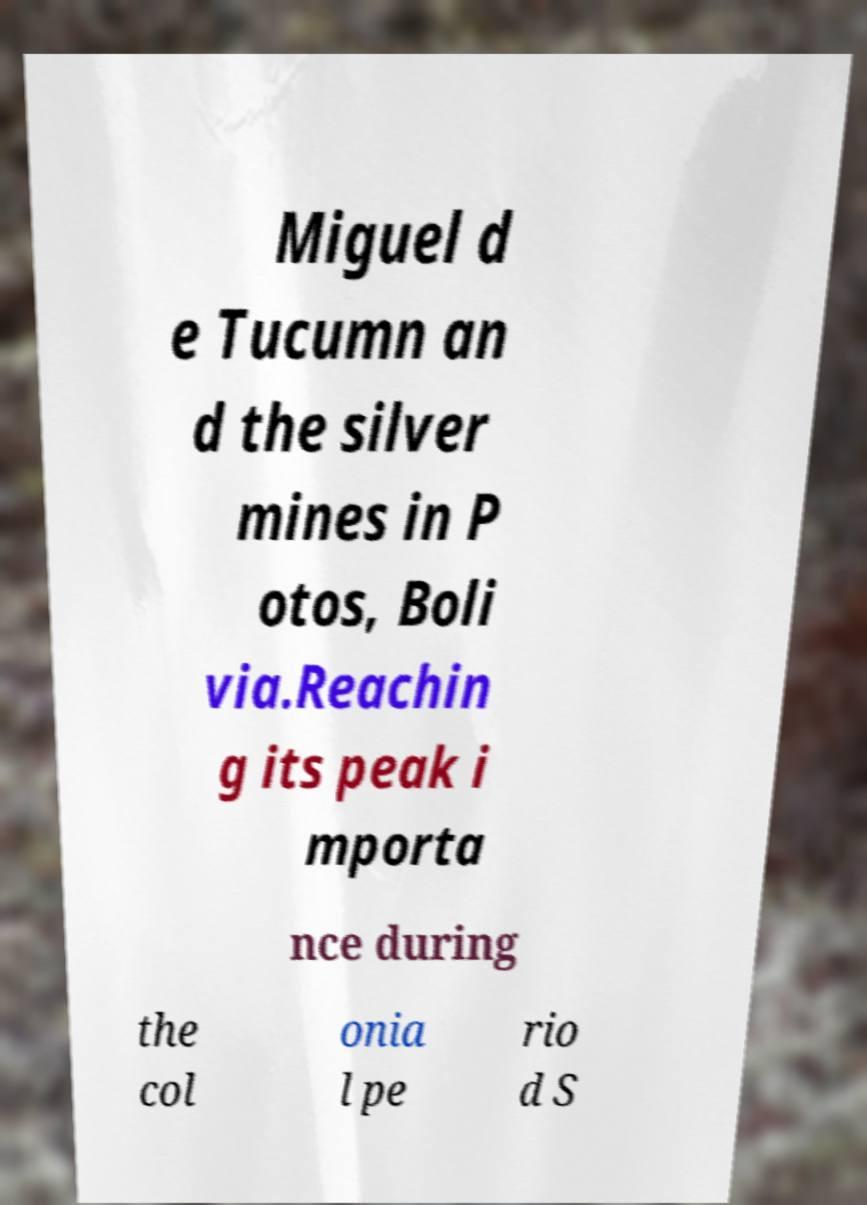Can you read and provide the text displayed in the image?This photo seems to have some interesting text. Can you extract and type it out for me? Miguel d e Tucumn an d the silver mines in P otos, Boli via.Reachin g its peak i mporta nce during the col onia l pe rio d S 